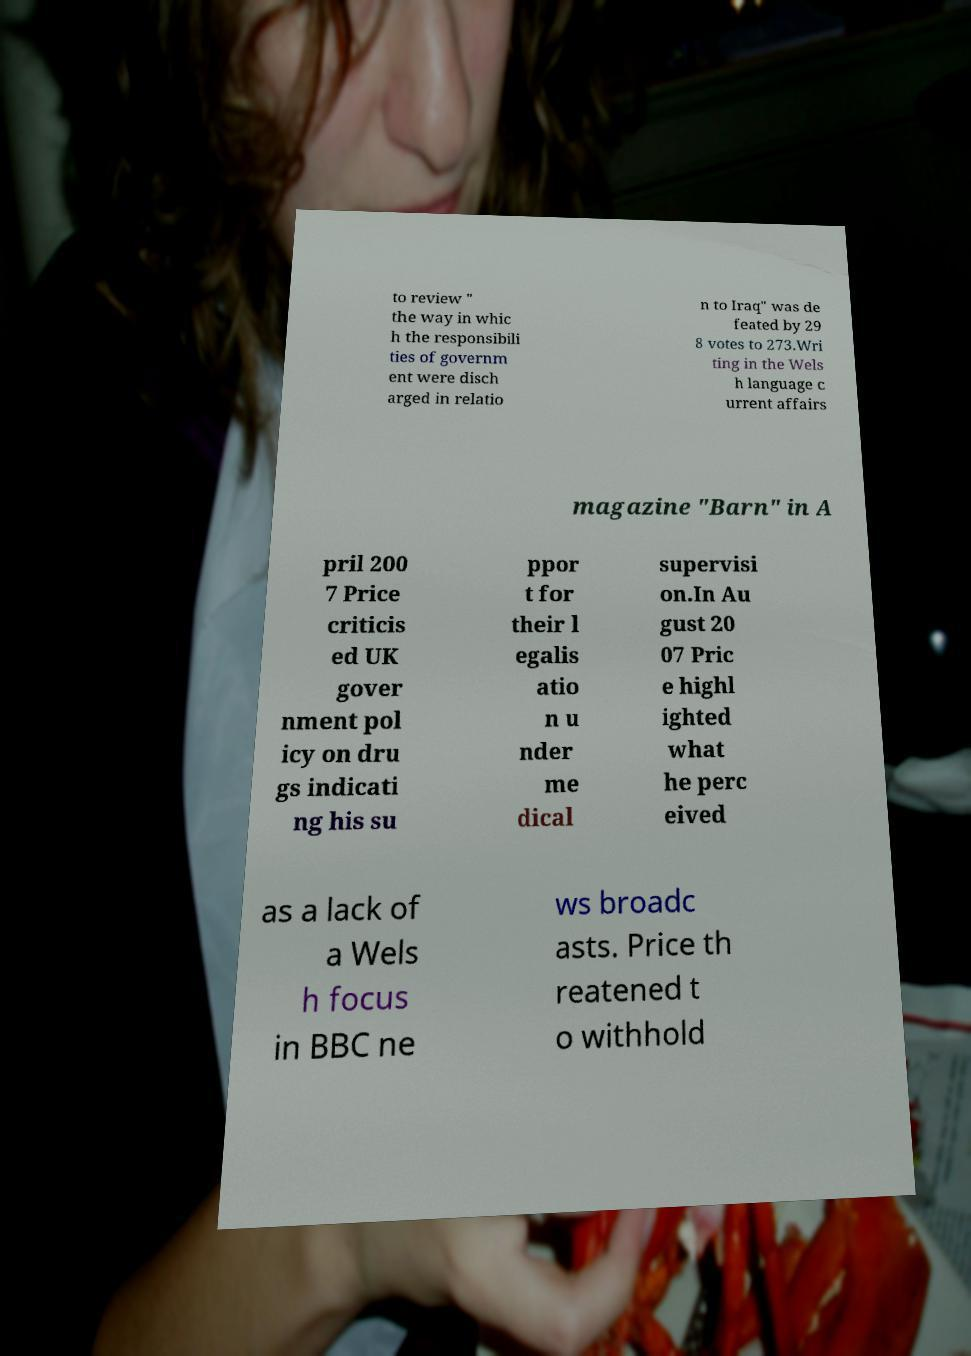Please identify and transcribe the text found in this image. to review " the way in whic h the responsibili ties of governm ent were disch arged in relatio n to Iraq" was de feated by 29 8 votes to 273.Wri ting in the Wels h language c urrent affairs magazine "Barn" in A pril 200 7 Price criticis ed UK gover nment pol icy on dru gs indicati ng his su ppor t for their l egalis atio n u nder me dical supervisi on.In Au gust 20 07 Pric e highl ighted what he perc eived as a lack of a Wels h focus in BBC ne ws broadc asts. Price th reatened t o withhold 